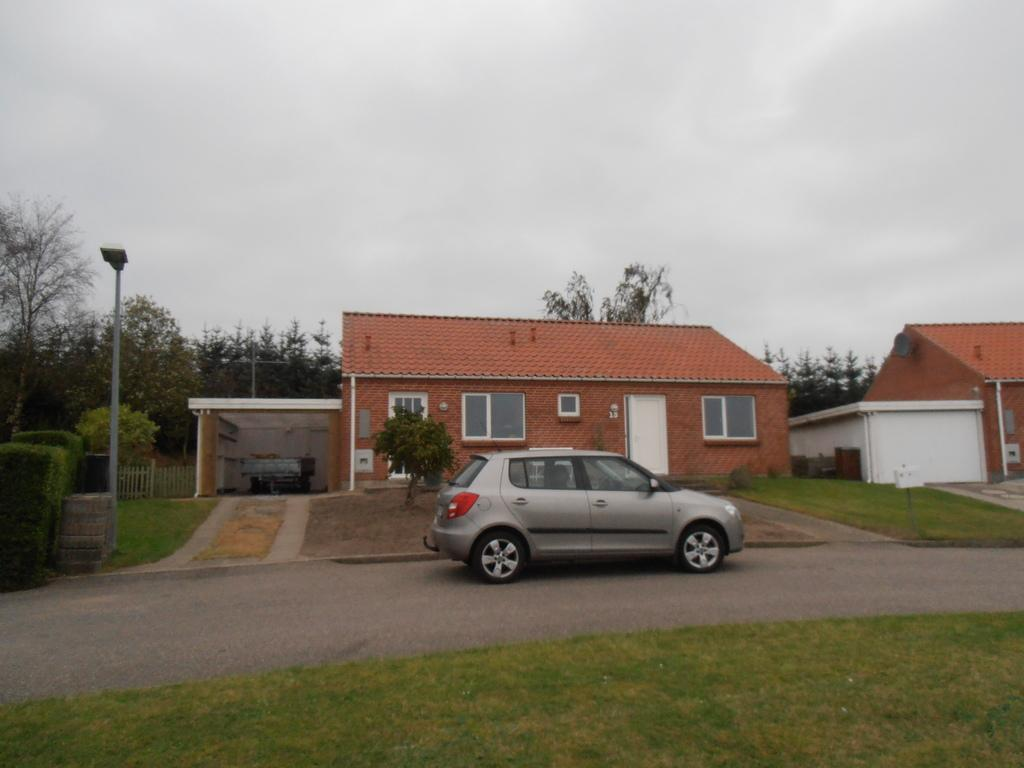What is the main subject of the image? The main subject of the image is a car on the road. What can be seen beside the road? There are houses beside the road. What type of vegetation is present in the image? Grass, plants, and trees are present in the image. What structures are visible in the image? Electric poles are in the image. What else can be seen in the image besides the car and vegetation? There are other objects in the image. What is visible in the background of the image? The sky is visible in the background of the image. What type of brass instrument is being played by the box in the image? There is no box or brass instrument present in the image. 